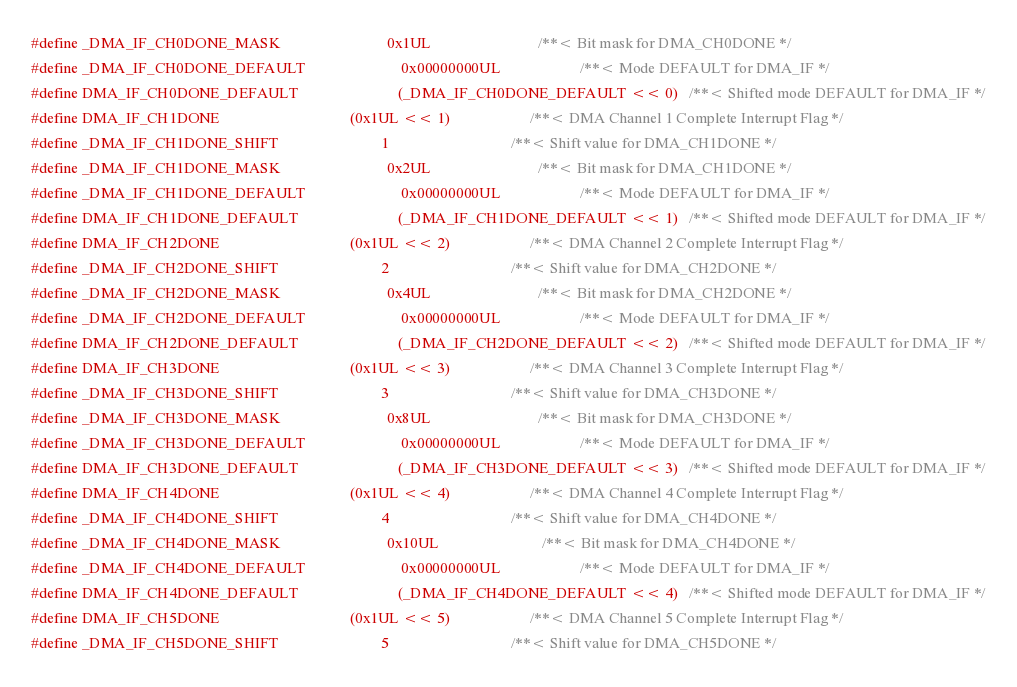<code> <loc_0><loc_0><loc_500><loc_500><_C_>#define _DMA_IF_CH0DONE_MASK                            0x1UL                            /**< Bit mask for DMA_CH0DONE */
#define _DMA_IF_CH0DONE_DEFAULT                         0x00000000UL                     /**< Mode DEFAULT for DMA_IF */
#define DMA_IF_CH0DONE_DEFAULT                          (_DMA_IF_CH0DONE_DEFAULT << 0)   /**< Shifted mode DEFAULT for DMA_IF */
#define DMA_IF_CH1DONE                                  (0x1UL << 1)                     /**< DMA Channel 1 Complete Interrupt Flag */
#define _DMA_IF_CH1DONE_SHIFT                           1                                /**< Shift value for DMA_CH1DONE */
#define _DMA_IF_CH1DONE_MASK                            0x2UL                            /**< Bit mask for DMA_CH1DONE */
#define _DMA_IF_CH1DONE_DEFAULT                         0x00000000UL                     /**< Mode DEFAULT for DMA_IF */
#define DMA_IF_CH1DONE_DEFAULT                          (_DMA_IF_CH1DONE_DEFAULT << 1)   /**< Shifted mode DEFAULT for DMA_IF */
#define DMA_IF_CH2DONE                                  (0x1UL << 2)                     /**< DMA Channel 2 Complete Interrupt Flag */
#define _DMA_IF_CH2DONE_SHIFT                           2                                /**< Shift value for DMA_CH2DONE */
#define _DMA_IF_CH2DONE_MASK                            0x4UL                            /**< Bit mask for DMA_CH2DONE */
#define _DMA_IF_CH2DONE_DEFAULT                         0x00000000UL                     /**< Mode DEFAULT for DMA_IF */
#define DMA_IF_CH2DONE_DEFAULT                          (_DMA_IF_CH2DONE_DEFAULT << 2)   /**< Shifted mode DEFAULT for DMA_IF */
#define DMA_IF_CH3DONE                                  (0x1UL << 3)                     /**< DMA Channel 3 Complete Interrupt Flag */
#define _DMA_IF_CH3DONE_SHIFT                           3                                /**< Shift value for DMA_CH3DONE */
#define _DMA_IF_CH3DONE_MASK                            0x8UL                            /**< Bit mask for DMA_CH3DONE */
#define _DMA_IF_CH3DONE_DEFAULT                         0x00000000UL                     /**< Mode DEFAULT for DMA_IF */
#define DMA_IF_CH3DONE_DEFAULT                          (_DMA_IF_CH3DONE_DEFAULT << 3)   /**< Shifted mode DEFAULT for DMA_IF */
#define DMA_IF_CH4DONE                                  (0x1UL << 4)                     /**< DMA Channel 4 Complete Interrupt Flag */
#define _DMA_IF_CH4DONE_SHIFT                           4                                /**< Shift value for DMA_CH4DONE */
#define _DMA_IF_CH4DONE_MASK                            0x10UL                           /**< Bit mask for DMA_CH4DONE */
#define _DMA_IF_CH4DONE_DEFAULT                         0x00000000UL                     /**< Mode DEFAULT for DMA_IF */
#define DMA_IF_CH4DONE_DEFAULT                          (_DMA_IF_CH4DONE_DEFAULT << 4)   /**< Shifted mode DEFAULT for DMA_IF */
#define DMA_IF_CH5DONE                                  (0x1UL << 5)                     /**< DMA Channel 5 Complete Interrupt Flag */
#define _DMA_IF_CH5DONE_SHIFT                           5                                /**< Shift value for DMA_CH5DONE */</code> 